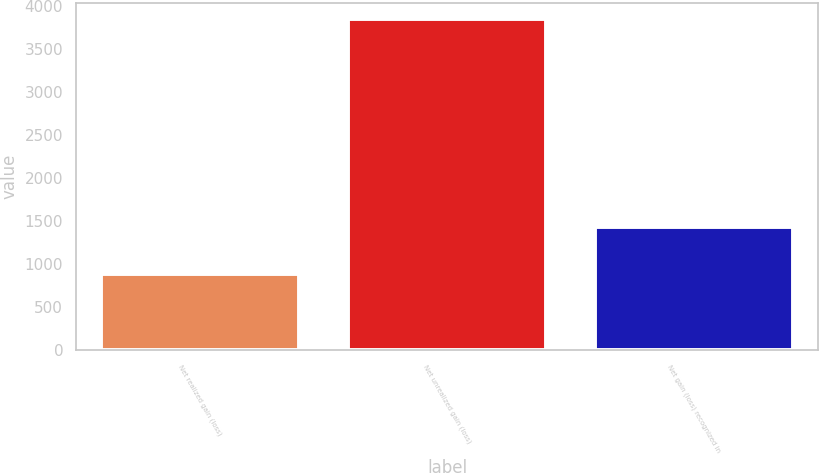Convert chart. <chart><loc_0><loc_0><loc_500><loc_500><bar_chart><fcel>Net realized gain (loss)<fcel>Net unrealized gain (loss)<fcel>Net gain (loss) recognized in<nl><fcel>882<fcel>3843<fcel>1432<nl></chart> 